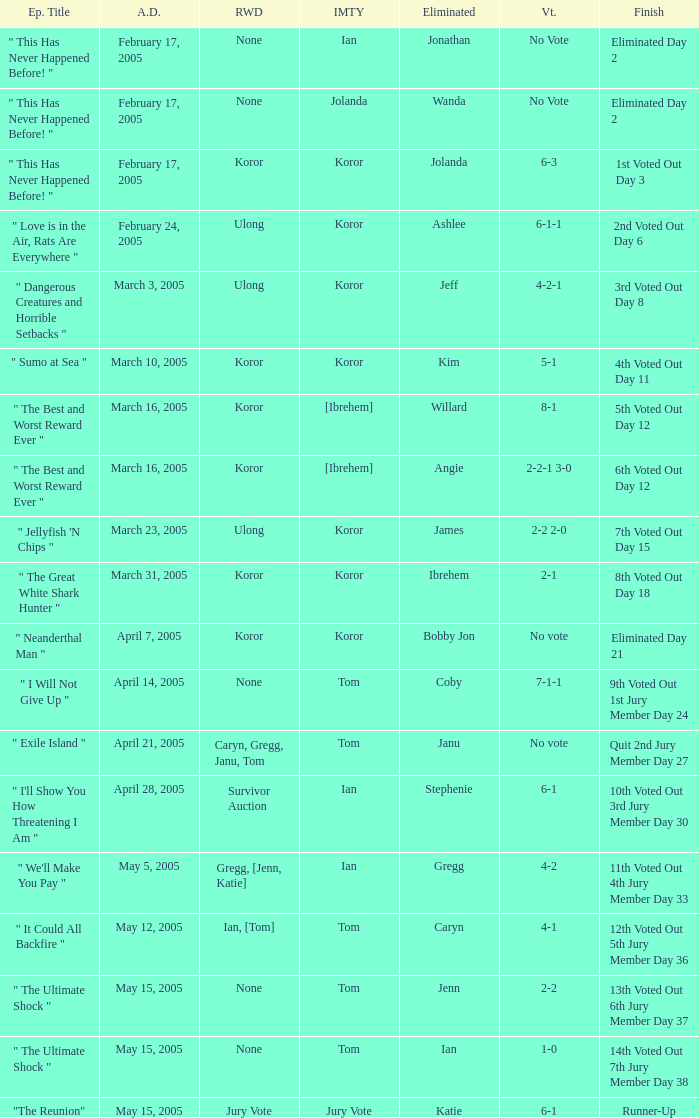How many persons had immunity in the episode when Wanda was eliminated? 1.0. 